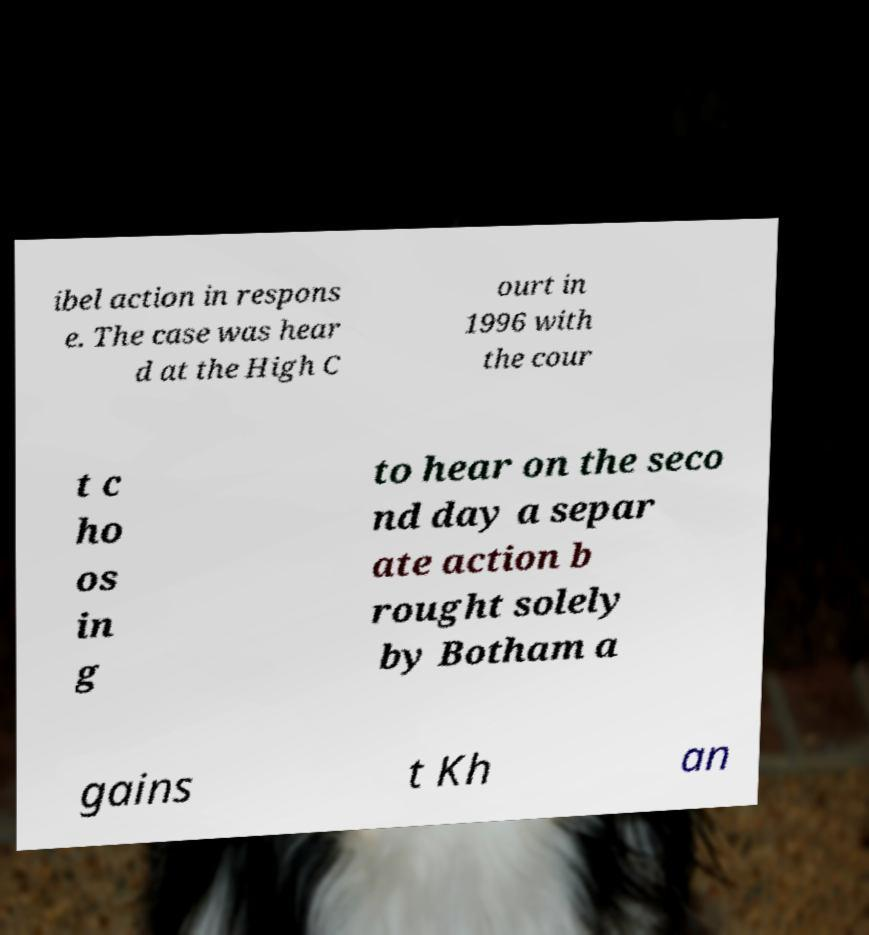What messages or text are displayed in this image? I need them in a readable, typed format. ibel action in respons e. The case was hear d at the High C ourt in 1996 with the cour t c ho os in g to hear on the seco nd day a separ ate action b rought solely by Botham a gains t Kh an 